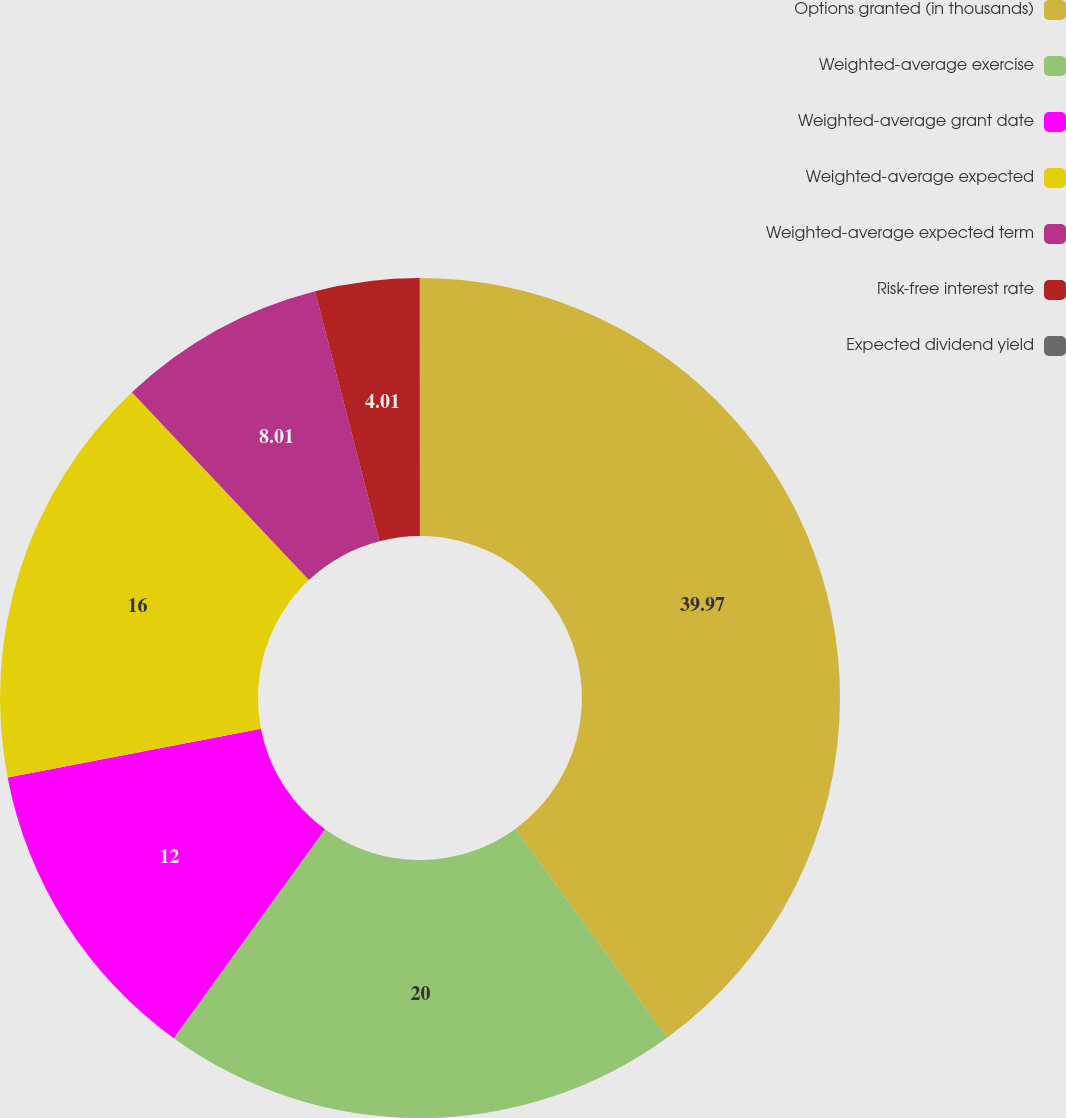Convert chart. <chart><loc_0><loc_0><loc_500><loc_500><pie_chart><fcel>Options granted (in thousands)<fcel>Weighted-average exercise<fcel>Weighted-average grant date<fcel>Weighted-average expected<fcel>Weighted-average expected term<fcel>Risk-free interest rate<fcel>Expected dividend yield<nl><fcel>39.98%<fcel>20.0%<fcel>12.0%<fcel>16.0%<fcel>8.01%<fcel>4.01%<fcel>0.01%<nl></chart> 